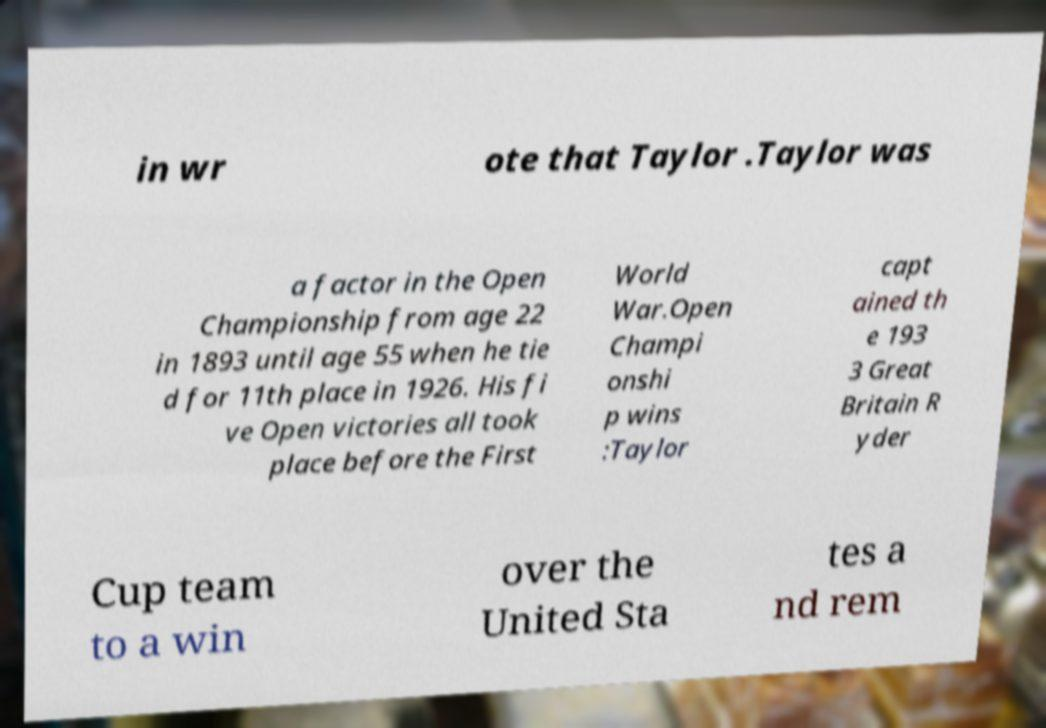There's text embedded in this image that I need extracted. Can you transcribe it verbatim? in wr ote that Taylor .Taylor was a factor in the Open Championship from age 22 in 1893 until age 55 when he tie d for 11th place in 1926. His fi ve Open victories all took place before the First World War.Open Champi onshi p wins :Taylor capt ained th e 193 3 Great Britain R yder Cup team to a win over the United Sta tes a nd rem 